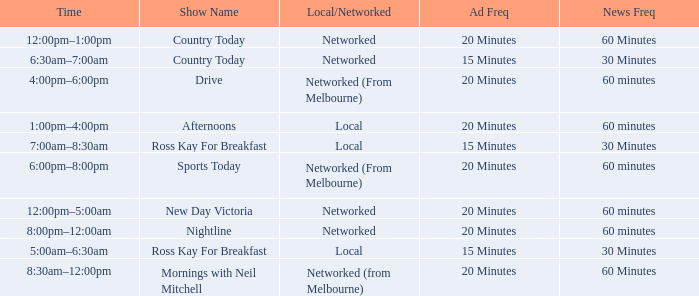What Time has Ad Freq of 15 minutes, and a Show Name of country today? 6:30am–7:00am. 